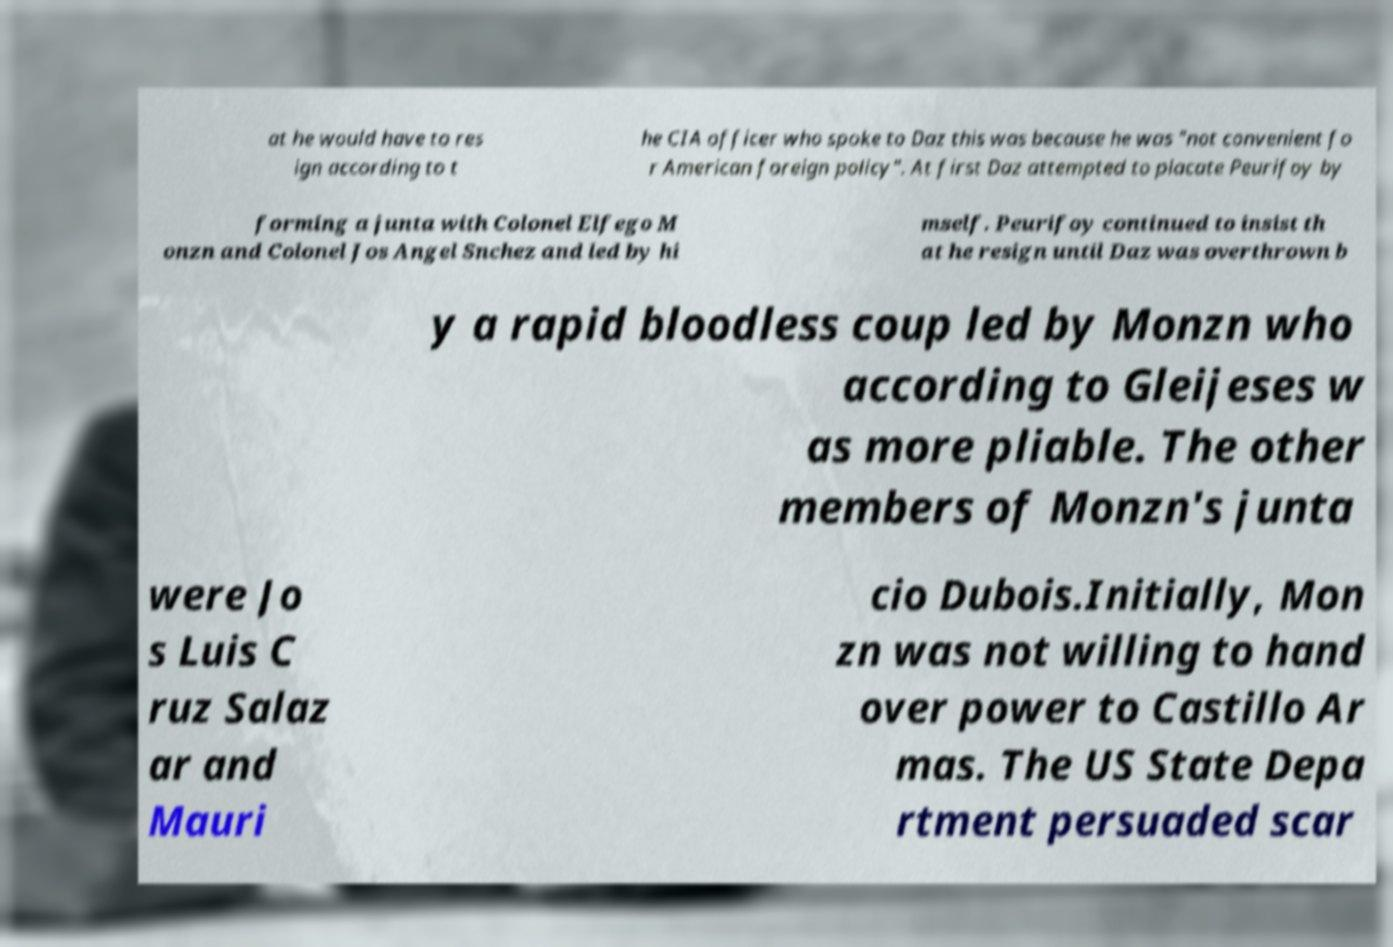There's text embedded in this image that I need extracted. Can you transcribe it verbatim? at he would have to res ign according to t he CIA officer who spoke to Daz this was because he was "not convenient fo r American foreign policy". At first Daz attempted to placate Peurifoy by forming a junta with Colonel Elfego M onzn and Colonel Jos Angel Snchez and led by hi mself. Peurifoy continued to insist th at he resign until Daz was overthrown b y a rapid bloodless coup led by Monzn who according to Gleijeses w as more pliable. The other members of Monzn's junta were Jo s Luis C ruz Salaz ar and Mauri cio Dubois.Initially, Mon zn was not willing to hand over power to Castillo Ar mas. The US State Depa rtment persuaded scar 